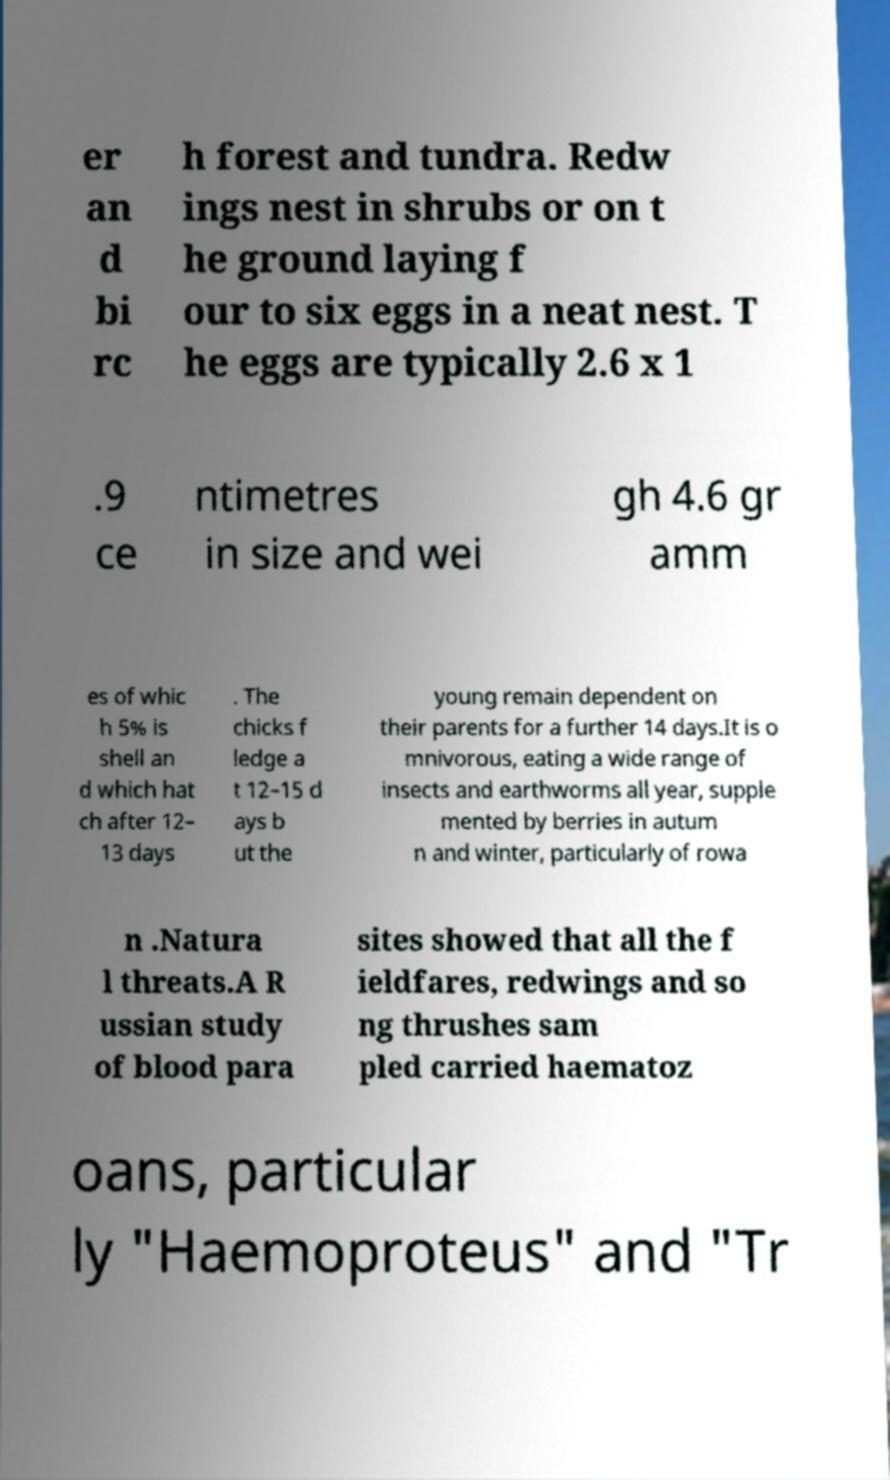Can you accurately transcribe the text from the provided image for me? er an d bi rc h forest and tundra. Redw ings nest in shrubs or on t he ground laying f our to six eggs in a neat nest. T he eggs are typically 2.6 x 1 .9 ce ntimetres in size and wei gh 4.6 gr amm es of whic h 5% is shell an d which hat ch after 12– 13 days . The chicks f ledge a t 12–15 d ays b ut the young remain dependent on their parents for a further 14 days.It is o mnivorous, eating a wide range of insects and earthworms all year, supple mented by berries in autum n and winter, particularly of rowa n .Natura l threats.A R ussian study of blood para sites showed that all the f ieldfares, redwings and so ng thrushes sam pled carried haematoz oans, particular ly "Haemoproteus" and "Tr 